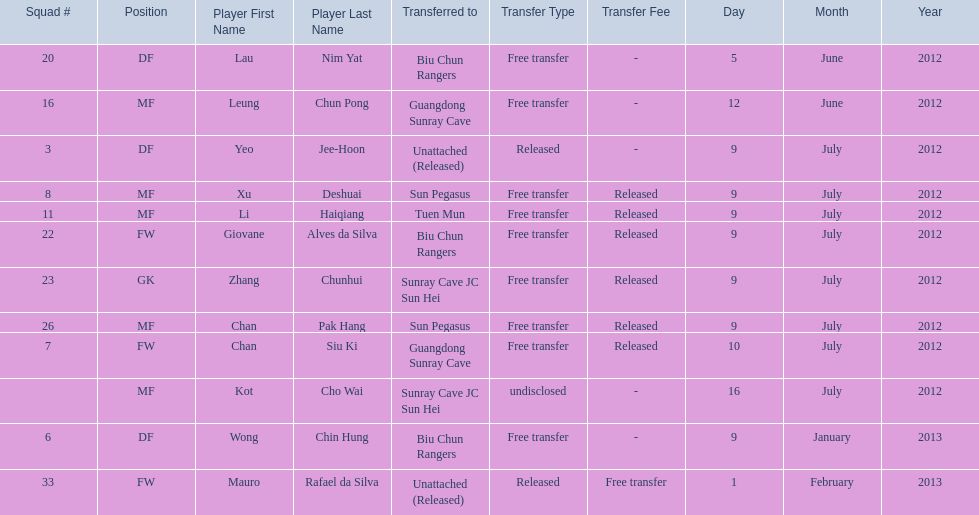Which players played during the 2012-13 south china aa season? Lau Nim Yat, Leung Chun Pong, Yeo Jee-Hoon, Xu Deshuai, Li Haiqiang, Giovane Alves da Silva, Zhang Chunhui, Chan Pak Hang, Chan Siu Ki, Kot Cho Wai, Wong Chin Hung, Mauro Rafael da Silva. Of these, which were free transfers that were not released? Lau Nim Yat, Leung Chun Pong, Wong Chin Hung, Mauro Rafael da Silva. Of these, which were in squad # 6? Wong Chin Hung. What was the date of his transfer? 9 January 2013. 